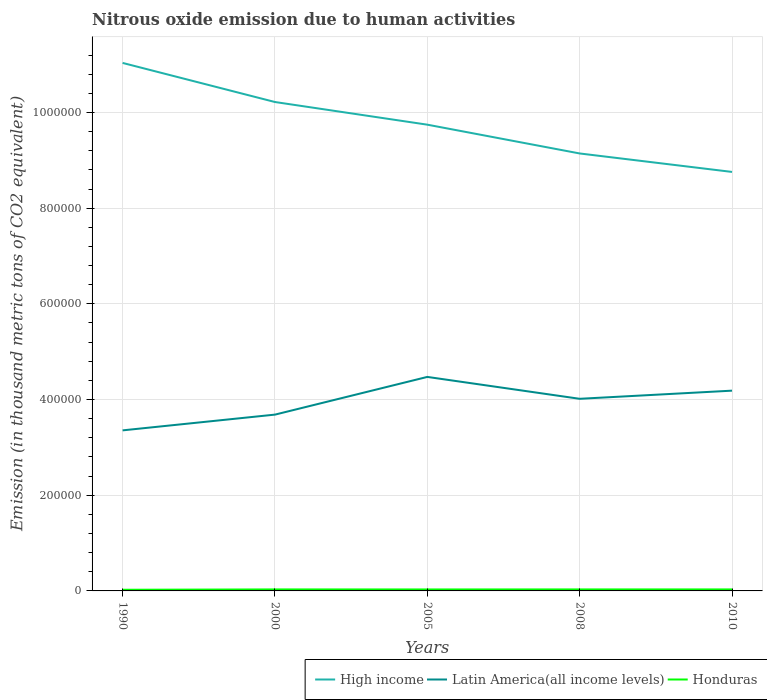Does the line corresponding to High income intersect with the line corresponding to Latin America(all income levels)?
Ensure brevity in your answer.  No. Is the number of lines equal to the number of legend labels?
Keep it short and to the point. Yes. Across all years, what is the maximum amount of nitrous oxide emitted in Honduras?
Provide a succinct answer. 2427.6. In which year was the amount of nitrous oxide emitted in High income maximum?
Keep it short and to the point. 2010. What is the total amount of nitrous oxide emitted in High income in the graph?
Provide a short and direct response. 2.28e+05. What is the difference between the highest and the second highest amount of nitrous oxide emitted in Latin America(all income levels)?
Your answer should be very brief. 1.12e+05. What is the difference between the highest and the lowest amount of nitrous oxide emitted in High income?
Provide a short and direct response. 2. Is the amount of nitrous oxide emitted in Latin America(all income levels) strictly greater than the amount of nitrous oxide emitted in Honduras over the years?
Make the answer very short. No. Are the values on the major ticks of Y-axis written in scientific E-notation?
Keep it short and to the point. No. Does the graph contain any zero values?
Your response must be concise. No. Does the graph contain grids?
Provide a short and direct response. Yes. Where does the legend appear in the graph?
Ensure brevity in your answer.  Bottom right. How many legend labels are there?
Offer a very short reply. 3. What is the title of the graph?
Provide a short and direct response. Nitrous oxide emission due to human activities. What is the label or title of the Y-axis?
Your response must be concise. Emission (in thousand metric tons of CO2 equivalent). What is the Emission (in thousand metric tons of CO2 equivalent) in High income in 1990?
Ensure brevity in your answer.  1.10e+06. What is the Emission (in thousand metric tons of CO2 equivalent) of Latin America(all income levels) in 1990?
Your answer should be compact. 3.36e+05. What is the Emission (in thousand metric tons of CO2 equivalent) of Honduras in 1990?
Ensure brevity in your answer.  2427.6. What is the Emission (in thousand metric tons of CO2 equivalent) in High income in 2000?
Your response must be concise. 1.02e+06. What is the Emission (in thousand metric tons of CO2 equivalent) in Latin America(all income levels) in 2000?
Provide a short and direct response. 3.68e+05. What is the Emission (in thousand metric tons of CO2 equivalent) in Honduras in 2000?
Your response must be concise. 3142.2. What is the Emission (in thousand metric tons of CO2 equivalent) in High income in 2005?
Provide a short and direct response. 9.74e+05. What is the Emission (in thousand metric tons of CO2 equivalent) of Latin America(all income levels) in 2005?
Offer a terse response. 4.47e+05. What is the Emission (in thousand metric tons of CO2 equivalent) of Honduras in 2005?
Ensure brevity in your answer.  3064.9. What is the Emission (in thousand metric tons of CO2 equivalent) in High income in 2008?
Offer a very short reply. 9.14e+05. What is the Emission (in thousand metric tons of CO2 equivalent) of Latin America(all income levels) in 2008?
Your answer should be compact. 4.02e+05. What is the Emission (in thousand metric tons of CO2 equivalent) in Honduras in 2008?
Make the answer very short. 3139.2. What is the Emission (in thousand metric tons of CO2 equivalent) in High income in 2010?
Ensure brevity in your answer.  8.76e+05. What is the Emission (in thousand metric tons of CO2 equivalent) of Latin America(all income levels) in 2010?
Provide a succinct answer. 4.19e+05. What is the Emission (in thousand metric tons of CO2 equivalent) of Honduras in 2010?
Give a very brief answer. 3143.4. Across all years, what is the maximum Emission (in thousand metric tons of CO2 equivalent) in High income?
Offer a terse response. 1.10e+06. Across all years, what is the maximum Emission (in thousand metric tons of CO2 equivalent) in Latin America(all income levels)?
Your response must be concise. 4.47e+05. Across all years, what is the maximum Emission (in thousand metric tons of CO2 equivalent) of Honduras?
Give a very brief answer. 3143.4. Across all years, what is the minimum Emission (in thousand metric tons of CO2 equivalent) in High income?
Your answer should be compact. 8.76e+05. Across all years, what is the minimum Emission (in thousand metric tons of CO2 equivalent) of Latin America(all income levels)?
Offer a very short reply. 3.36e+05. Across all years, what is the minimum Emission (in thousand metric tons of CO2 equivalent) of Honduras?
Provide a succinct answer. 2427.6. What is the total Emission (in thousand metric tons of CO2 equivalent) in High income in the graph?
Your answer should be compact. 4.89e+06. What is the total Emission (in thousand metric tons of CO2 equivalent) of Latin America(all income levels) in the graph?
Offer a terse response. 1.97e+06. What is the total Emission (in thousand metric tons of CO2 equivalent) of Honduras in the graph?
Provide a succinct answer. 1.49e+04. What is the difference between the Emission (in thousand metric tons of CO2 equivalent) of High income in 1990 and that in 2000?
Provide a succinct answer. 8.17e+04. What is the difference between the Emission (in thousand metric tons of CO2 equivalent) of Latin America(all income levels) in 1990 and that in 2000?
Your response must be concise. -3.29e+04. What is the difference between the Emission (in thousand metric tons of CO2 equivalent) of Honduras in 1990 and that in 2000?
Offer a very short reply. -714.6. What is the difference between the Emission (in thousand metric tons of CO2 equivalent) of High income in 1990 and that in 2005?
Your answer should be compact. 1.29e+05. What is the difference between the Emission (in thousand metric tons of CO2 equivalent) of Latin America(all income levels) in 1990 and that in 2005?
Make the answer very short. -1.12e+05. What is the difference between the Emission (in thousand metric tons of CO2 equivalent) in Honduras in 1990 and that in 2005?
Your answer should be compact. -637.3. What is the difference between the Emission (in thousand metric tons of CO2 equivalent) of High income in 1990 and that in 2008?
Your answer should be compact. 1.89e+05. What is the difference between the Emission (in thousand metric tons of CO2 equivalent) in Latin America(all income levels) in 1990 and that in 2008?
Your answer should be compact. -6.60e+04. What is the difference between the Emission (in thousand metric tons of CO2 equivalent) in Honduras in 1990 and that in 2008?
Provide a short and direct response. -711.6. What is the difference between the Emission (in thousand metric tons of CO2 equivalent) in High income in 1990 and that in 2010?
Offer a terse response. 2.28e+05. What is the difference between the Emission (in thousand metric tons of CO2 equivalent) in Latin America(all income levels) in 1990 and that in 2010?
Give a very brief answer. -8.30e+04. What is the difference between the Emission (in thousand metric tons of CO2 equivalent) of Honduras in 1990 and that in 2010?
Your response must be concise. -715.8. What is the difference between the Emission (in thousand metric tons of CO2 equivalent) of High income in 2000 and that in 2005?
Give a very brief answer. 4.74e+04. What is the difference between the Emission (in thousand metric tons of CO2 equivalent) of Latin America(all income levels) in 2000 and that in 2005?
Your answer should be compact. -7.88e+04. What is the difference between the Emission (in thousand metric tons of CO2 equivalent) in Honduras in 2000 and that in 2005?
Provide a succinct answer. 77.3. What is the difference between the Emission (in thousand metric tons of CO2 equivalent) in High income in 2000 and that in 2008?
Your answer should be compact. 1.08e+05. What is the difference between the Emission (in thousand metric tons of CO2 equivalent) in Latin America(all income levels) in 2000 and that in 2008?
Make the answer very short. -3.31e+04. What is the difference between the Emission (in thousand metric tons of CO2 equivalent) of Honduras in 2000 and that in 2008?
Provide a short and direct response. 3. What is the difference between the Emission (in thousand metric tons of CO2 equivalent) of High income in 2000 and that in 2010?
Give a very brief answer. 1.46e+05. What is the difference between the Emission (in thousand metric tons of CO2 equivalent) of Latin America(all income levels) in 2000 and that in 2010?
Make the answer very short. -5.01e+04. What is the difference between the Emission (in thousand metric tons of CO2 equivalent) of Honduras in 2000 and that in 2010?
Your response must be concise. -1.2. What is the difference between the Emission (in thousand metric tons of CO2 equivalent) of High income in 2005 and that in 2008?
Your response must be concise. 6.02e+04. What is the difference between the Emission (in thousand metric tons of CO2 equivalent) of Latin America(all income levels) in 2005 and that in 2008?
Ensure brevity in your answer.  4.57e+04. What is the difference between the Emission (in thousand metric tons of CO2 equivalent) of Honduras in 2005 and that in 2008?
Ensure brevity in your answer.  -74.3. What is the difference between the Emission (in thousand metric tons of CO2 equivalent) of High income in 2005 and that in 2010?
Offer a terse response. 9.88e+04. What is the difference between the Emission (in thousand metric tons of CO2 equivalent) of Latin America(all income levels) in 2005 and that in 2010?
Your answer should be very brief. 2.87e+04. What is the difference between the Emission (in thousand metric tons of CO2 equivalent) of Honduras in 2005 and that in 2010?
Your answer should be very brief. -78.5. What is the difference between the Emission (in thousand metric tons of CO2 equivalent) in High income in 2008 and that in 2010?
Make the answer very short. 3.86e+04. What is the difference between the Emission (in thousand metric tons of CO2 equivalent) in Latin America(all income levels) in 2008 and that in 2010?
Offer a very short reply. -1.70e+04. What is the difference between the Emission (in thousand metric tons of CO2 equivalent) in Honduras in 2008 and that in 2010?
Give a very brief answer. -4.2. What is the difference between the Emission (in thousand metric tons of CO2 equivalent) in High income in 1990 and the Emission (in thousand metric tons of CO2 equivalent) in Latin America(all income levels) in 2000?
Offer a very short reply. 7.35e+05. What is the difference between the Emission (in thousand metric tons of CO2 equivalent) in High income in 1990 and the Emission (in thousand metric tons of CO2 equivalent) in Honduras in 2000?
Make the answer very short. 1.10e+06. What is the difference between the Emission (in thousand metric tons of CO2 equivalent) of Latin America(all income levels) in 1990 and the Emission (in thousand metric tons of CO2 equivalent) of Honduras in 2000?
Give a very brief answer. 3.32e+05. What is the difference between the Emission (in thousand metric tons of CO2 equivalent) of High income in 1990 and the Emission (in thousand metric tons of CO2 equivalent) of Latin America(all income levels) in 2005?
Provide a succinct answer. 6.56e+05. What is the difference between the Emission (in thousand metric tons of CO2 equivalent) in High income in 1990 and the Emission (in thousand metric tons of CO2 equivalent) in Honduras in 2005?
Provide a succinct answer. 1.10e+06. What is the difference between the Emission (in thousand metric tons of CO2 equivalent) of Latin America(all income levels) in 1990 and the Emission (in thousand metric tons of CO2 equivalent) of Honduras in 2005?
Ensure brevity in your answer.  3.32e+05. What is the difference between the Emission (in thousand metric tons of CO2 equivalent) in High income in 1990 and the Emission (in thousand metric tons of CO2 equivalent) in Latin America(all income levels) in 2008?
Your response must be concise. 7.02e+05. What is the difference between the Emission (in thousand metric tons of CO2 equivalent) in High income in 1990 and the Emission (in thousand metric tons of CO2 equivalent) in Honduras in 2008?
Your answer should be compact. 1.10e+06. What is the difference between the Emission (in thousand metric tons of CO2 equivalent) in Latin America(all income levels) in 1990 and the Emission (in thousand metric tons of CO2 equivalent) in Honduras in 2008?
Provide a short and direct response. 3.32e+05. What is the difference between the Emission (in thousand metric tons of CO2 equivalent) in High income in 1990 and the Emission (in thousand metric tons of CO2 equivalent) in Latin America(all income levels) in 2010?
Provide a short and direct response. 6.85e+05. What is the difference between the Emission (in thousand metric tons of CO2 equivalent) in High income in 1990 and the Emission (in thousand metric tons of CO2 equivalent) in Honduras in 2010?
Keep it short and to the point. 1.10e+06. What is the difference between the Emission (in thousand metric tons of CO2 equivalent) of Latin America(all income levels) in 1990 and the Emission (in thousand metric tons of CO2 equivalent) of Honduras in 2010?
Provide a short and direct response. 3.32e+05. What is the difference between the Emission (in thousand metric tons of CO2 equivalent) of High income in 2000 and the Emission (in thousand metric tons of CO2 equivalent) of Latin America(all income levels) in 2005?
Give a very brief answer. 5.75e+05. What is the difference between the Emission (in thousand metric tons of CO2 equivalent) of High income in 2000 and the Emission (in thousand metric tons of CO2 equivalent) of Honduras in 2005?
Your response must be concise. 1.02e+06. What is the difference between the Emission (in thousand metric tons of CO2 equivalent) in Latin America(all income levels) in 2000 and the Emission (in thousand metric tons of CO2 equivalent) in Honduras in 2005?
Your answer should be very brief. 3.65e+05. What is the difference between the Emission (in thousand metric tons of CO2 equivalent) in High income in 2000 and the Emission (in thousand metric tons of CO2 equivalent) in Latin America(all income levels) in 2008?
Give a very brief answer. 6.20e+05. What is the difference between the Emission (in thousand metric tons of CO2 equivalent) in High income in 2000 and the Emission (in thousand metric tons of CO2 equivalent) in Honduras in 2008?
Offer a terse response. 1.02e+06. What is the difference between the Emission (in thousand metric tons of CO2 equivalent) of Latin America(all income levels) in 2000 and the Emission (in thousand metric tons of CO2 equivalent) of Honduras in 2008?
Your answer should be very brief. 3.65e+05. What is the difference between the Emission (in thousand metric tons of CO2 equivalent) in High income in 2000 and the Emission (in thousand metric tons of CO2 equivalent) in Latin America(all income levels) in 2010?
Make the answer very short. 6.03e+05. What is the difference between the Emission (in thousand metric tons of CO2 equivalent) in High income in 2000 and the Emission (in thousand metric tons of CO2 equivalent) in Honduras in 2010?
Ensure brevity in your answer.  1.02e+06. What is the difference between the Emission (in thousand metric tons of CO2 equivalent) of Latin America(all income levels) in 2000 and the Emission (in thousand metric tons of CO2 equivalent) of Honduras in 2010?
Offer a very short reply. 3.65e+05. What is the difference between the Emission (in thousand metric tons of CO2 equivalent) in High income in 2005 and the Emission (in thousand metric tons of CO2 equivalent) in Latin America(all income levels) in 2008?
Your response must be concise. 5.73e+05. What is the difference between the Emission (in thousand metric tons of CO2 equivalent) of High income in 2005 and the Emission (in thousand metric tons of CO2 equivalent) of Honduras in 2008?
Your answer should be compact. 9.71e+05. What is the difference between the Emission (in thousand metric tons of CO2 equivalent) in Latin America(all income levels) in 2005 and the Emission (in thousand metric tons of CO2 equivalent) in Honduras in 2008?
Offer a terse response. 4.44e+05. What is the difference between the Emission (in thousand metric tons of CO2 equivalent) of High income in 2005 and the Emission (in thousand metric tons of CO2 equivalent) of Latin America(all income levels) in 2010?
Your answer should be very brief. 5.56e+05. What is the difference between the Emission (in thousand metric tons of CO2 equivalent) of High income in 2005 and the Emission (in thousand metric tons of CO2 equivalent) of Honduras in 2010?
Offer a terse response. 9.71e+05. What is the difference between the Emission (in thousand metric tons of CO2 equivalent) in Latin America(all income levels) in 2005 and the Emission (in thousand metric tons of CO2 equivalent) in Honduras in 2010?
Your answer should be very brief. 4.44e+05. What is the difference between the Emission (in thousand metric tons of CO2 equivalent) of High income in 2008 and the Emission (in thousand metric tons of CO2 equivalent) of Latin America(all income levels) in 2010?
Offer a terse response. 4.96e+05. What is the difference between the Emission (in thousand metric tons of CO2 equivalent) in High income in 2008 and the Emission (in thousand metric tons of CO2 equivalent) in Honduras in 2010?
Keep it short and to the point. 9.11e+05. What is the difference between the Emission (in thousand metric tons of CO2 equivalent) in Latin America(all income levels) in 2008 and the Emission (in thousand metric tons of CO2 equivalent) in Honduras in 2010?
Your answer should be compact. 3.98e+05. What is the average Emission (in thousand metric tons of CO2 equivalent) of High income per year?
Your response must be concise. 9.78e+05. What is the average Emission (in thousand metric tons of CO2 equivalent) in Latin America(all income levels) per year?
Make the answer very short. 3.94e+05. What is the average Emission (in thousand metric tons of CO2 equivalent) of Honduras per year?
Provide a short and direct response. 2983.46. In the year 1990, what is the difference between the Emission (in thousand metric tons of CO2 equivalent) in High income and Emission (in thousand metric tons of CO2 equivalent) in Latin America(all income levels)?
Your answer should be compact. 7.68e+05. In the year 1990, what is the difference between the Emission (in thousand metric tons of CO2 equivalent) of High income and Emission (in thousand metric tons of CO2 equivalent) of Honduras?
Offer a very short reply. 1.10e+06. In the year 1990, what is the difference between the Emission (in thousand metric tons of CO2 equivalent) in Latin America(all income levels) and Emission (in thousand metric tons of CO2 equivalent) in Honduras?
Offer a very short reply. 3.33e+05. In the year 2000, what is the difference between the Emission (in thousand metric tons of CO2 equivalent) of High income and Emission (in thousand metric tons of CO2 equivalent) of Latin America(all income levels)?
Offer a terse response. 6.53e+05. In the year 2000, what is the difference between the Emission (in thousand metric tons of CO2 equivalent) in High income and Emission (in thousand metric tons of CO2 equivalent) in Honduras?
Your response must be concise. 1.02e+06. In the year 2000, what is the difference between the Emission (in thousand metric tons of CO2 equivalent) in Latin America(all income levels) and Emission (in thousand metric tons of CO2 equivalent) in Honduras?
Keep it short and to the point. 3.65e+05. In the year 2005, what is the difference between the Emission (in thousand metric tons of CO2 equivalent) in High income and Emission (in thousand metric tons of CO2 equivalent) in Latin America(all income levels)?
Your answer should be very brief. 5.27e+05. In the year 2005, what is the difference between the Emission (in thousand metric tons of CO2 equivalent) of High income and Emission (in thousand metric tons of CO2 equivalent) of Honduras?
Provide a short and direct response. 9.71e+05. In the year 2005, what is the difference between the Emission (in thousand metric tons of CO2 equivalent) in Latin America(all income levels) and Emission (in thousand metric tons of CO2 equivalent) in Honduras?
Your response must be concise. 4.44e+05. In the year 2008, what is the difference between the Emission (in thousand metric tons of CO2 equivalent) in High income and Emission (in thousand metric tons of CO2 equivalent) in Latin America(all income levels)?
Your response must be concise. 5.13e+05. In the year 2008, what is the difference between the Emission (in thousand metric tons of CO2 equivalent) in High income and Emission (in thousand metric tons of CO2 equivalent) in Honduras?
Keep it short and to the point. 9.11e+05. In the year 2008, what is the difference between the Emission (in thousand metric tons of CO2 equivalent) in Latin America(all income levels) and Emission (in thousand metric tons of CO2 equivalent) in Honduras?
Your response must be concise. 3.98e+05. In the year 2010, what is the difference between the Emission (in thousand metric tons of CO2 equivalent) of High income and Emission (in thousand metric tons of CO2 equivalent) of Latin America(all income levels)?
Provide a succinct answer. 4.57e+05. In the year 2010, what is the difference between the Emission (in thousand metric tons of CO2 equivalent) in High income and Emission (in thousand metric tons of CO2 equivalent) in Honduras?
Your answer should be very brief. 8.73e+05. In the year 2010, what is the difference between the Emission (in thousand metric tons of CO2 equivalent) in Latin America(all income levels) and Emission (in thousand metric tons of CO2 equivalent) in Honduras?
Your response must be concise. 4.15e+05. What is the ratio of the Emission (in thousand metric tons of CO2 equivalent) in High income in 1990 to that in 2000?
Your response must be concise. 1.08. What is the ratio of the Emission (in thousand metric tons of CO2 equivalent) in Latin America(all income levels) in 1990 to that in 2000?
Keep it short and to the point. 0.91. What is the ratio of the Emission (in thousand metric tons of CO2 equivalent) of Honduras in 1990 to that in 2000?
Make the answer very short. 0.77. What is the ratio of the Emission (in thousand metric tons of CO2 equivalent) of High income in 1990 to that in 2005?
Provide a short and direct response. 1.13. What is the ratio of the Emission (in thousand metric tons of CO2 equivalent) in Latin America(all income levels) in 1990 to that in 2005?
Ensure brevity in your answer.  0.75. What is the ratio of the Emission (in thousand metric tons of CO2 equivalent) in Honduras in 1990 to that in 2005?
Ensure brevity in your answer.  0.79. What is the ratio of the Emission (in thousand metric tons of CO2 equivalent) of High income in 1990 to that in 2008?
Make the answer very short. 1.21. What is the ratio of the Emission (in thousand metric tons of CO2 equivalent) in Latin America(all income levels) in 1990 to that in 2008?
Make the answer very short. 0.84. What is the ratio of the Emission (in thousand metric tons of CO2 equivalent) in Honduras in 1990 to that in 2008?
Provide a succinct answer. 0.77. What is the ratio of the Emission (in thousand metric tons of CO2 equivalent) of High income in 1990 to that in 2010?
Give a very brief answer. 1.26. What is the ratio of the Emission (in thousand metric tons of CO2 equivalent) in Latin America(all income levels) in 1990 to that in 2010?
Make the answer very short. 0.8. What is the ratio of the Emission (in thousand metric tons of CO2 equivalent) of Honduras in 1990 to that in 2010?
Your response must be concise. 0.77. What is the ratio of the Emission (in thousand metric tons of CO2 equivalent) of High income in 2000 to that in 2005?
Give a very brief answer. 1.05. What is the ratio of the Emission (in thousand metric tons of CO2 equivalent) of Latin America(all income levels) in 2000 to that in 2005?
Provide a succinct answer. 0.82. What is the ratio of the Emission (in thousand metric tons of CO2 equivalent) in Honduras in 2000 to that in 2005?
Provide a short and direct response. 1.03. What is the ratio of the Emission (in thousand metric tons of CO2 equivalent) of High income in 2000 to that in 2008?
Keep it short and to the point. 1.12. What is the ratio of the Emission (in thousand metric tons of CO2 equivalent) of Latin America(all income levels) in 2000 to that in 2008?
Make the answer very short. 0.92. What is the ratio of the Emission (in thousand metric tons of CO2 equivalent) of Honduras in 2000 to that in 2008?
Provide a succinct answer. 1. What is the ratio of the Emission (in thousand metric tons of CO2 equivalent) of High income in 2000 to that in 2010?
Keep it short and to the point. 1.17. What is the ratio of the Emission (in thousand metric tons of CO2 equivalent) of Latin America(all income levels) in 2000 to that in 2010?
Keep it short and to the point. 0.88. What is the ratio of the Emission (in thousand metric tons of CO2 equivalent) in High income in 2005 to that in 2008?
Your answer should be compact. 1.07. What is the ratio of the Emission (in thousand metric tons of CO2 equivalent) in Latin America(all income levels) in 2005 to that in 2008?
Give a very brief answer. 1.11. What is the ratio of the Emission (in thousand metric tons of CO2 equivalent) in Honduras in 2005 to that in 2008?
Provide a succinct answer. 0.98. What is the ratio of the Emission (in thousand metric tons of CO2 equivalent) of High income in 2005 to that in 2010?
Ensure brevity in your answer.  1.11. What is the ratio of the Emission (in thousand metric tons of CO2 equivalent) of Latin America(all income levels) in 2005 to that in 2010?
Your answer should be very brief. 1.07. What is the ratio of the Emission (in thousand metric tons of CO2 equivalent) in Honduras in 2005 to that in 2010?
Provide a succinct answer. 0.97. What is the ratio of the Emission (in thousand metric tons of CO2 equivalent) in High income in 2008 to that in 2010?
Give a very brief answer. 1.04. What is the ratio of the Emission (in thousand metric tons of CO2 equivalent) in Latin America(all income levels) in 2008 to that in 2010?
Offer a terse response. 0.96. What is the ratio of the Emission (in thousand metric tons of CO2 equivalent) of Honduras in 2008 to that in 2010?
Give a very brief answer. 1. What is the difference between the highest and the second highest Emission (in thousand metric tons of CO2 equivalent) of High income?
Offer a terse response. 8.17e+04. What is the difference between the highest and the second highest Emission (in thousand metric tons of CO2 equivalent) of Latin America(all income levels)?
Offer a very short reply. 2.87e+04. What is the difference between the highest and the second highest Emission (in thousand metric tons of CO2 equivalent) in Honduras?
Give a very brief answer. 1.2. What is the difference between the highest and the lowest Emission (in thousand metric tons of CO2 equivalent) of High income?
Provide a succinct answer. 2.28e+05. What is the difference between the highest and the lowest Emission (in thousand metric tons of CO2 equivalent) in Latin America(all income levels)?
Your answer should be very brief. 1.12e+05. What is the difference between the highest and the lowest Emission (in thousand metric tons of CO2 equivalent) of Honduras?
Your response must be concise. 715.8. 